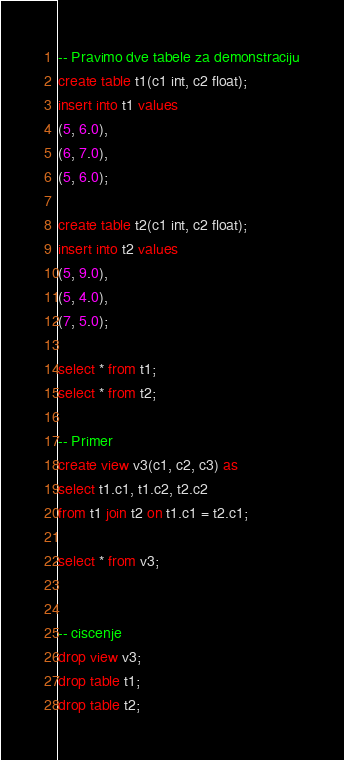<code> <loc_0><loc_0><loc_500><loc_500><_SQL_>-- Pravimo dve tabele za demonstraciju
create table t1(c1 int, c2 float);
insert into t1 values 
(5, 6.0),
(6, 7.0),
(5, 6.0);

create table t2(c1 int, c2 float);
insert into t2 values 
(5, 9.0),
(5, 4.0),
(7, 5.0);

select * from t1;
select * from t2;

-- Primer
create view v3(c1, c2, c3) as
select t1.c1, t1.c2, t2.c2
from t1 join t2 on t1.c1 = t2.c1;

select * from v3;


-- ciscenje
drop view v3;
drop table t1;
drop table t2;</code> 